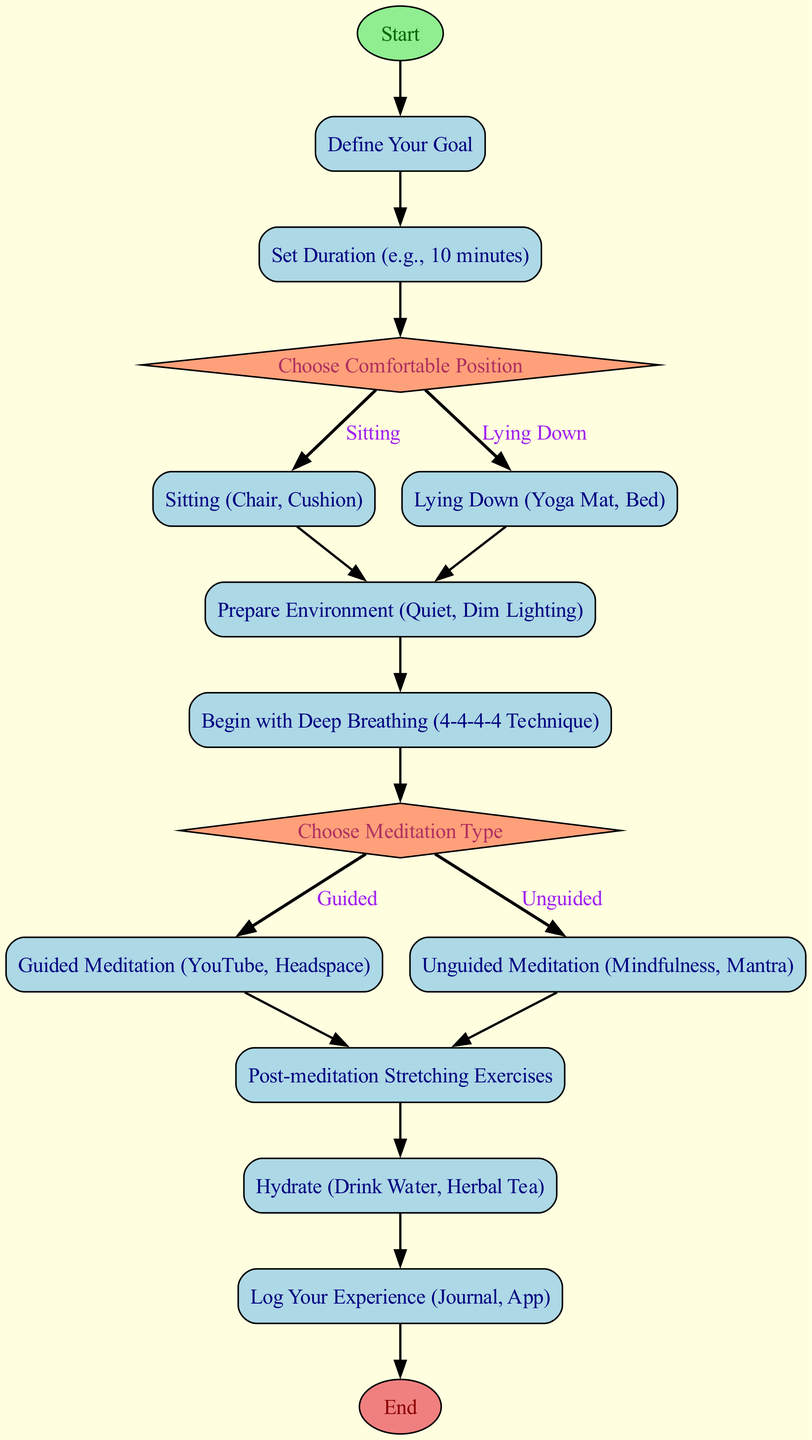What is the first step in the diagram? The first step in the diagram is labeled "Start." It is the initial node from which the flow begins, indicating the start of the process.
Answer: Start How many types of meditation are offered in the routine? The routine offers two types of meditation: guided and unguided. Each type is distinctly laid out as options following the decision node regarding meditation type.
Answer: Two What should you do after setting the duration? After setting the duration, the next step is to "Choose Comfortable Position." The flow chart clearly shows the direction from setting the duration to selecting a position.
Answer: Choose Comfortable Position What is the label of the node after "Post-meditation Stretching Exercises"? The node after "Post-meditation Stretching Exercises" is labeled "Hydrate." This is a direct progression from the stretching exercises to the next action to be taken.
Answer: Hydrate What condition leads to the choice of 'Unguided Meditation'? The condition that leads to choosing 'Unguided Meditation' is "Unguided." This is explicitly stated in the flowchart as a separate branch from the decision node regarding the type of meditation chosen.
Answer: Unguided How many edges connect the "Prepare Environment" node to the next steps? There is one edge connecting the "Prepare Environment" node to the next step, which is "Begin with Deep Breathing." This shows a single progression from preparing the environment to starting breathing exercises.
Answer: One What is the last step of the routine? The last step of the routine is labeled "End." This indicates the conclusion of the entire meditation and recovery process as described in the flowchart.
Answer: End What is the second node in the flowchart? The second node in the flowchart is labeled "Define Your Goal." This follows directly after the starting node and specifies an important early step in the process.
Answer: Define Your Goal If you choose 'Lying Down', what is the next step? If you choose 'Lying Down', the next step is to "Prepare Environment." This indicates a progression after deciding on a comfortable lying position to set up for meditation.
Answer: Prepare Environment 